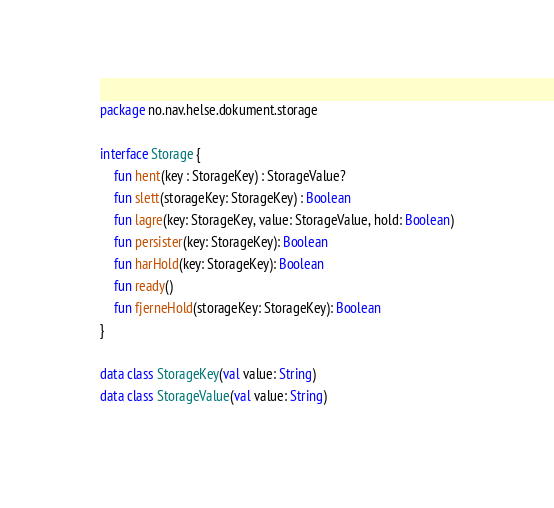Convert code to text. <code><loc_0><loc_0><loc_500><loc_500><_Kotlin_>package no.nav.helse.dokument.storage

interface Storage {
    fun hent(key : StorageKey) : StorageValue?
    fun slett(storageKey: StorageKey) : Boolean
    fun lagre(key: StorageKey, value: StorageValue, hold: Boolean)
    fun persister(key: StorageKey): Boolean
    fun harHold(key: StorageKey): Boolean
    fun ready()
    fun fjerneHold(storageKey: StorageKey): Boolean
}

data class StorageKey(val value: String)
data class StorageValue(val value: String)
</code> 